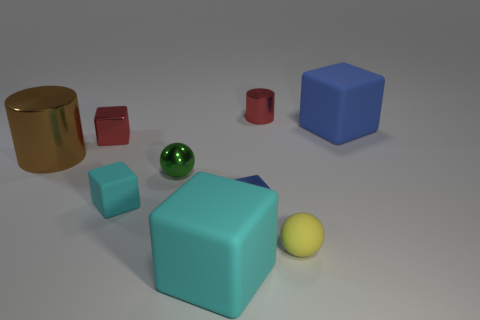Subtract all tiny cyan cubes. How many cubes are left? 4 Subtract all red blocks. How many blocks are left? 4 Subtract all purple blocks. Subtract all blue cylinders. How many blocks are left? 5 Add 1 red shiny blocks. How many objects exist? 10 Subtract all cylinders. How many objects are left? 7 Subtract all big red matte cubes. Subtract all small blue metallic objects. How many objects are left? 8 Add 7 large blocks. How many large blocks are left? 9 Add 6 small blue metal cylinders. How many small blue metal cylinders exist? 6 Subtract 1 brown cylinders. How many objects are left? 8 